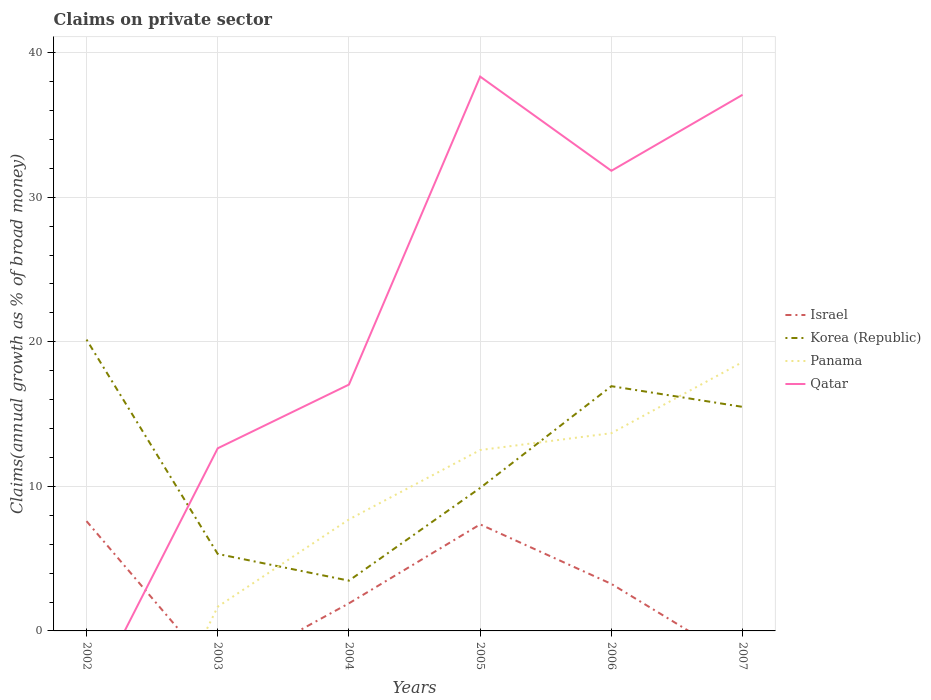How many different coloured lines are there?
Offer a very short reply. 4. Does the line corresponding to Panama intersect with the line corresponding to Israel?
Your response must be concise. Yes. Is the number of lines equal to the number of legend labels?
Your answer should be very brief. No. Across all years, what is the maximum percentage of broad money claimed on private sector in Panama?
Your response must be concise. 0. What is the total percentage of broad money claimed on private sector in Israel in the graph?
Provide a short and direct response. -5.46. What is the difference between the highest and the second highest percentage of broad money claimed on private sector in Korea (Republic)?
Offer a terse response. 16.68. What is the difference between the highest and the lowest percentage of broad money claimed on private sector in Qatar?
Provide a succinct answer. 3. Is the percentage of broad money claimed on private sector in Korea (Republic) strictly greater than the percentage of broad money claimed on private sector in Qatar over the years?
Your answer should be compact. No. How many lines are there?
Offer a terse response. 4. How many years are there in the graph?
Provide a short and direct response. 6. What is the difference between two consecutive major ticks on the Y-axis?
Give a very brief answer. 10. Are the values on the major ticks of Y-axis written in scientific E-notation?
Provide a succinct answer. No. Does the graph contain any zero values?
Make the answer very short. Yes. Does the graph contain grids?
Give a very brief answer. Yes. What is the title of the graph?
Ensure brevity in your answer.  Claims on private sector. What is the label or title of the X-axis?
Your answer should be compact. Years. What is the label or title of the Y-axis?
Keep it short and to the point. Claims(annual growth as % of broad money). What is the Claims(annual growth as % of broad money) of Israel in 2002?
Provide a short and direct response. 7.59. What is the Claims(annual growth as % of broad money) in Korea (Republic) in 2002?
Offer a very short reply. 20.15. What is the Claims(annual growth as % of broad money) of Israel in 2003?
Your response must be concise. 0. What is the Claims(annual growth as % of broad money) in Korea (Republic) in 2003?
Provide a succinct answer. 5.32. What is the Claims(annual growth as % of broad money) in Panama in 2003?
Offer a terse response. 1.67. What is the Claims(annual growth as % of broad money) of Qatar in 2003?
Make the answer very short. 12.63. What is the Claims(annual growth as % of broad money) in Israel in 2004?
Give a very brief answer. 1.91. What is the Claims(annual growth as % of broad money) in Korea (Republic) in 2004?
Your response must be concise. 3.48. What is the Claims(annual growth as % of broad money) of Panama in 2004?
Make the answer very short. 7.71. What is the Claims(annual growth as % of broad money) of Qatar in 2004?
Provide a short and direct response. 17.04. What is the Claims(annual growth as % of broad money) of Israel in 2005?
Provide a short and direct response. 7.37. What is the Claims(annual growth as % of broad money) of Korea (Republic) in 2005?
Provide a succinct answer. 9.89. What is the Claims(annual growth as % of broad money) of Panama in 2005?
Your answer should be very brief. 12.51. What is the Claims(annual growth as % of broad money) in Qatar in 2005?
Provide a succinct answer. 38.35. What is the Claims(annual growth as % of broad money) in Israel in 2006?
Keep it short and to the point. 3.25. What is the Claims(annual growth as % of broad money) in Korea (Republic) in 2006?
Offer a very short reply. 16.93. What is the Claims(annual growth as % of broad money) in Panama in 2006?
Provide a short and direct response. 13.68. What is the Claims(annual growth as % of broad money) of Qatar in 2006?
Your response must be concise. 31.83. What is the Claims(annual growth as % of broad money) of Korea (Republic) in 2007?
Your answer should be very brief. 15.5. What is the Claims(annual growth as % of broad money) in Panama in 2007?
Keep it short and to the point. 18.6. What is the Claims(annual growth as % of broad money) of Qatar in 2007?
Your answer should be compact. 37.09. Across all years, what is the maximum Claims(annual growth as % of broad money) of Israel?
Offer a very short reply. 7.59. Across all years, what is the maximum Claims(annual growth as % of broad money) in Korea (Republic)?
Provide a short and direct response. 20.15. Across all years, what is the maximum Claims(annual growth as % of broad money) of Panama?
Provide a succinct answer. 18.6. Across all years, what is the maximum Claims(annual growth as % of broad money) of Qatar?
Offer a terse response. 38.35. Across all years, what is the minimum Claims(annual growth as % of broad money) of Israel?
Your answer should be very brief. 0. Across all years, what is the minimum Claims(annual growth as % of broad money) of Korea (Republic)?
Offer a terse response. 3.48. What is the total Claims(annual growth as % of broad money) in Israel in the graph?
Your answer should be compact. 20.13. What is the total Claims(annual growth as % of broad money) in Korea (Republic) in the graph?
Offer a terse response. 71.27. What is the total Claims(annual growth as % of broad money) of Panama in the graph?
Provide a succinct answer. 54.18. What is the total Claims(annual growth as % of broad money) of Qatar in the graph?
Offer a very short reply. 136.94. What is the difference between the Claims(annual growth as % of broad money) in Korea (Republic) in 2002 and that in 2003?
Offer a terse response. 14.83. What is the difference between the Claims(annual growth as % of broad money) in Israel in 2002 and that in 2004?
Provide a succinct answer. 5.69. What is the difference between the Claims(annual growth as % of broad money) in Korea (Republic) in 2002 and that in 2004?
Your answer should be very brief. 16.68. What is the difference between the Claims(annual growth as % of broad money) of Israel in 2002 and that in 2005?
Offer a very short reply. 0.23. What is the difference between the Claims(annual growth as % of broad money) of Korea (Republic) in 2002 and that in 2005?
Your answer should be very brief. 10.26. What is the difference between the Claims(annual growth as % of broad money) of Israel in 2002 and that in 2006?
Your response must be concise. 4.34. What is the difference between the Claims(annual growth as % of broad money) of Korea (Republic) in 2002 and that in 2006?
Your response must be concise. 3.22. What is the difference between the Claims(annual growth as % of broad money) in Korea (Republic) in 2002 and that in 2007?
Provide a short and direct response. 4.65. What is the difference between the Claims(annual growth as % of broad money) of Korea (Republic) in 2003 and that in 2004?
Provide a short and direct response. 1.85. What is the difference between the Claims(annual growth as % of broad money) in Panama in 2003 and that in 2004?
Keep it short and to the point. -6.04. What is the difference between the Claims(annual growth as % of broad money) of Qatar in 2003 and that in 2004?
Provide a succinct answer. -4.41. What is the difference between the Claims(annual growth as % of broad money) in Korea (Republic) in 2003 and that in 2005?
Ensure brevity in your answer.  -4.57. What is the difference between the Claims(annual growth as % of broad money) of Panama in 2003 and that in 2005?
Your answer should be compact. -10.84. What is the difference between the Claims(annual growth as % of broad money) of Qatar in 2003 and that in 2005?
Make the answer very short. -25.71. What is the difference between the Claims(annual growth as % of broad money) of Korea (Republic) in 2003 and that in 2006?
Your answer should be compact. -11.61. What is the difference between the Claims(annual growth as % of broad money) in Panama in 2003 and that in 2006?
Your answer should be very brief. -12. What is the difference between the Claims(annual growth as % of broad money) of Qatar in 2003 and that in 2006?
Make the answer very short. -19.2. What is the difference between the Claims(annual growth as % of broad money) in Korea (Republic) in 2003 and that in 2007?
Provide a succinct answer. -10.17. What is the difference between the Claims(annual growth as % of broad money) in Panama in 2003 and that in 2007?
Your response must be concise. -16.93. What is the difference between the Claims(annual growth as % of broad money) of Qatar in 2003 and that in 2007?
Your answer should be very brief. -24.45. What is the difference between the Claims(annual growth as % of broad money) of Israel in 2004 and that in 2005?
Your answer should be compact. -5.46. What is the difference between the Claims(annual growth as % of broad money) of Korea (Republic) in 2004 and that in 2005?
Your answer should be very brief. -6.41. What is the difference between the Claims(annual growth as % of broad money) of Panama in 2004 and that in 2005?
Your answer should be compact. -4.8. What is the difference between the Claims(annual growth as % of broad money) in Qatar in 2004 and that in 2005?
Keep it short and to the point. -21.31. What is the difference between the Claims(annual growth as % of broad money) in Israel in 2004 and that in 2006?
Provide a succinct answer. -1.34. What is the difference between the Claims(annual growth as % of broad money) in Korea (Republic) in 2004 and that in 2006?
Make the answer very short. -13.45. What is the difference between the Claims(annual growth as % of broad money) of Panama in 2004 and that in 2006?
Offer a very short reply. -5.97. What is the difference between the Claims(annual growth as % of broad money) of Qatar in 2004 and that in 2006?
Keep it short and to the point. -14.79. What is the difference between the Claims(annual growth as % of broad money) of Korea (Republic) in 2004 and that in 2007?
Provide a short and direct response. -12.02. What is the difference between the Claims(annual growth as % of broad money) in Panama in 2004 and that in 2007?
Make the answer very short. -10.89. What is the difference between the Claims(annual growth as % of broad money) of Qatar in 2004 and that in 2007?
Keep it short and to the point. -20.05. What is the difference between the Claims(annual growth as % of broad money) of Israel in 2005 and that in 2006?
Keep it short and to the point. 4.12. What is the difference between the Claims(annual growth as % of broad money) in Korea (Republic) in 2005 and that in 2006?
Offer a terse response. -7.04. What is the difference between the Claims(annual growth as % of broad money) in Panama in 2005 and that in 2006?
Keep it short and to the point. -1.17. What is the difference between the Claims(annual growth as % of broad money) in Qatar in 2005 and that in 2006?
Your response must be concise. 6.52. What is the difference between the Claims(annual growth as % of broad money) of Korea (Republic) in 2005 and that in 2007?
Give a very brief answer. -5.61. What is the difference between the Claims(annual growth as % of broad money) in Panama in 2005 and that in 2007?
Provide a short and direct response. -6.09. What is the difference between the Claims(annual growth as % of broad money) in Qatar in 2005 and that in 2007?
Your answer should be compact. 1.26. What is the difference between the Claims(annual growth as % of broad money) of Korea (Republic) in 2006 and that in 2007?
Your answer should be compact. 1.43. What is the difference between the Claims(annual growth as % of broad money) of Panama in 2006 and that in 2007?
Your answer should be compact. -4.92. What is the difference between the Claims(annual growth as % of broad money) in Qatar in 2006 and that in 2007?
Your response must be concise. -5.26. What is the difference between the Claims(annual growth as % of broad money) in Israel in 2002 and the Claims(annual growth as % of broad money) in Korea (Republic) in 2003?
Your response must be concise. 2.27. What is the difference between the Claims(annual growth as % of broad money) of Israel in 2002 and the Claims(annual growth as % of broad money) of Panama in 2003?
Your response must be concise. 5.92. What is the difference between the Claims(annual growth as % of broad money) in Israel in 2002 and the Claims(annual growth as % of broad money) in Qatar in 2003?
Your response must be concise. -5.04. What is the difference between the Claims(annual growth as % of broad money) of Korea (Republic) in 2002 and the Claims(annual growth as % of broad money) of Panama in 2003?
Your answer should be very brief. 18.48. What is the difference between the Claims(annual growth as % of broad money) of Korea (Republic) in 2002 and the Claims(annual growth as % of broad money) of Qatar in 2003?
Your answer should be compact. 7.52. What is the difference between the Claims(annual growth as % of broad money) of Israel in 2002 and the Claims(annual growth as % of broad money) of Korea (Republic) in 2004?
Provide a succinct answer. 4.12. What is the difference between the Claims(annual growth as % of broad money) in Israel in 2002 and the Claims(annual growth as % of broad money) in Panama in 2004?
Your answer should be compact. -0.12. What is the difference between the Claims(annual growth as % of broad money) in Israel in 2002 and the Claims(annual growth as % of broad money) in Qatar in 2004?
Make the answer very short. -9.45. What is the difference between the Claims(annual growth as % of broad money) of Korea (Republic) in 2002 and the Claims(annual growth as % of broad money) of Panama in 2004?
Offer a terse response. 12.44. What is the difference between the Claims(annual growth as % of broad money) of Korea (Republic) in 2002 and the Claims(annual growth as % of broad money) of Qatar in 2004?
Your answer should be very brief. 3.11. What is the difference between the Claims(annual growth as % of broad money) in Israel in 2002 and the Claims(annual growth as % of broad money) in Korea (Republic) in 2005?
Your answer should be compact. -2.3. What is the difference between the Claims(annual growth as % of broad money) in Israel in 2002 and the Claims(annual growth as % of broad money) in Panama in 2005?
Make the answer very short. -4.92. What is the difference between the Claims(annual growth as % of broad money) in Israel in 2002 and the Claims(annual growth as % of broad money) in Qatar in 2005?
Offer a very short reply. -30.75. What is the difference between the Claims(annual growth as % of broad money) in Korea (Republic) in 2002 and the Claims(annual growth as % of broad money) in Panama in 2005?
Offer a terse response. 7.64. What is the difference between the Claims(annual growth as % of broad money) in Korea (Republic) in 2002 and the Claims(annual growth as % of broad money) in Qatar in 2005?
Your answer should be very brief. -18.19. What is the difference between the Claims(annual growth as % of broad money) in Israel in 2002 and the Claims(annual growth as % of broad money) in Korea (Republic) in 2006?
Make the answer very short. -9.33. What is the difference between the Claims(annual growth as % of broad money) of Israel in 2002 and the Claims(annual growth as % of broad money) of Panama in 2006?
Offer a very short reply. -6.08. What is the difference between the Claims(annual growth as % of broad money) in Israel in 2002 and the Claims(annual growth as % of broad money) in Qatar in 2006?
Provide a succinct answer. -24.24. What is the difference between the Claims(annual growth as % of broad money) in Korea (Republic) in 2002 and the Claims(annual growth as % of broad money) in Panama in 2006?
Your answer should be very brief. 6.47. What is the difference between the Claims(annual growth as % of broad money) of Korea (Republic) in 2002 and the Claims(annual growth as % of broad money) of Qatar in 2006?
Offer a terse response. -11.68. What is the difference between the Claims(annual growth as % of broad money) of Israel in 2002 and the Claims(annual growth as % of broad money) of Korea (Republic) in 2007?
Your answer should be compact. -7.9. What is the difference between the Claims(annual growth as % of broad money) in Israel in 2002 and the Claims(annual growth as % of broad money) in Panama in 2007?
Provide a succinct answer. -11.01. What is the difference between the Claims(annual growth as % of broad money) in Israel in 2002 and the Claims(annual growth as % of broad money) in Qatar in 2007?
Keep it short and to the point. -29.49. What is the difference between the Claims(annual growth as % of broad money) of Korea (Republic) in 2002 and the Claims(annual growth as % of broad money) of Panama in 2007?
Make the answer very short. 1.55. What is the difference between the Claims(annual growth as % of broad money) of Korea (Republic) in 2002 and the Claims(annual growth as % of broad money) of Qatar in 2007?
Offer a very short reply. -16.94. What is the difference between the Claims(annual growth as % of broad money) in Korea (Republic) in 2003 and the Claims(annual growth as % of broad money) in Panama in 2004?
Provide a succinct answer. -2.39. What is the difference between the Claims(annual growth as % of broad money) in Korea (Republic) in 2003 and the Claims(annual growth as % of broad money) in Qatar in 2004?
Give a very brief answer. -11.72. What is the difference between the Claims(annual growth as % of broad money) in Panama in 2003 and the Claims(annual growth as % of broad money) in Qatar in 2004?
Your response must be concise. -15.37. What is the difference between the Claims(annual growth as % of broad money) in Korea (Republic) in 2003 and the Claims(annual growth as % of broad money) in Panama in 2005?
Provide a succinct answer. -7.19. What is the difference between the Claims(annual growth as % of broad money) in Korea (Republic) in 2003 and the Claims(annual growth as % of broad money) in Qatar in 2005?
Provide a succinct answer. -33.02. What is the difference between the Claims(annual growth as % of broad money) of Panama in 2003 and the Claims(annual growth as % of broad money) of Qatar in 2005?
Provide a succinct answer. -36.67. What is the difference between the Claims(annual growth as % of broad money) of Korea (Republic) in 2003 and the Claims(annual growth as % of broad money) of Panama in 2006?
Offer a terse response. -8.36. What is the difference between the Claims(annual growth as % of broad money) of Korea (Republic) in 2003 and the Claims(annual growth as % of broad money) of Qatar in 2006?
Make the answer very short. -26.51. What is the difference between the Claims(annual growth as % of broad money) of Panama in 2003 and the Claims(annual growth as % of broad money) of Qatar in 2006?
Offer a very short reply. -30.16. What is the difference between the Claims(annual growth as % of broad money) in Korea (Republic) in 2003 and the Claims(annual growth as % of broad money) in Panama in 2007?
Your answer should be compact. -13.28. What is the difference between the Claims(annual growth as % of broad money) in Korea (Republic) in 2003 and the Claims(annual growth as % of broad money) in Qatar in 2007?
Your answer should be compact. -31.76. What is the difference between the Claims(annual growth as % of broad money) of Panama in 2003 and the Claims(annual growth as % of broad money) of Qatar in 2007?
Make the answer very short. -35.41. What is the difference between the Claims(annual growth as % of broad money) in Israel in 2004 and the Claims(annual growth as % of broad money) in Korea (Republic) in 2005?
Your answer should be very brief. -7.98. What is the difference between the Claims(annual growth as % of broad money) in Israel in 2004 and the Claims(annual growth as % of broad money) in Panama in 2005?
Give a very brief answer. -10.6. What is the difference between the Claims(annual growth as % of broad money) of Israel in 2004 and the Claims(annual growth as % of broad money) of Qatar in 2005?
Your answer should be very brief. -36.44. What is the difference between the Claims(annual growth as % of broad money) in Korea (Republic) in 2004 and the Claims(annual growth as % of broad money) in Panama in 2005?
Offer a very short reply. -9.04. What is the difference between the Claims(annual growth as % of broad money) in Korea (Republic) in 2004 and the Claims(annual growth as % of broad money) in Qatar in 2005?
Ensure brevity in your answer.  -34.87. What is the difference between the Claims(annual growth as % of broad money) in Panama in 2004 and the Claims(annual growth as % of broad money) in Qatar in 2005?
Your answer should be compact. -30.63. What is the difference between the Claims(annual growth as % of broad money) of Israel in 2004 and the Claims(annual growth as % of broad money) of Korea (Republic) in 2006?
Provide a short and direct response. -15.02. What is the difference between the Claims(annual growth as % of broad money) of Israel in 2004 and the Claims(annual growth as % of broad money) of Panama in 2006?
Ensure brevity in your answer.  -11.77. What is the difference between the Claims(annual growth as % of broad money) of Israel in 2004 and the Claims(annual growth as % of broad money) of Qatar in 2006?
Offer a terse response. -29.92. What is the difference between the Claims(annual growth as % of broad money) in Korea (Republic) in 2004 and the Claims(annual growth as % of broad money) in Panama in 2006?
Ensure brevity in your answer.  -10.2. What is the difference between the Claims(annual growth as % of broad money) in Korea (Republic) in 2004 and the Claims(annual growth as % of broad money) in Qatar in 2006?
Give a very brief answer. -28.35. What is the difference between the Claims(annual growth as % of broad money) of Panama in 2004 and the Claims(annual growth as % of broad money) of Qatar in 2006?
Offer a very short reply. -24.12. What is the difference between the Claims(annual growth as % of broad money) in Israel in 2004 and the Claims(annual growth as % of broad money) in Korea (Republic) in 2007?
Your response must be concise. -13.59. What is the difference between the Claims(annual growth as % of broad money) in Israel in 2004 and the Claims(annual growth as % of broad money) in Panama in 2007?
Keep it short and to the point. -16.69. What is the difference between the Claims(annual growth as % of broad money) in Israel in 2004 and the Claims(annual growth as % of broad money) in Qatar in 2007?
Provide a succinct answer. -35.18. What is the difference between the Claims(annual growth as % of broad money) in Korea (Republic) in 2004 and the Claims(annual growth as % of broad money) in Panama in 2007?
Ensure brevity in your answer.  -15.12. What is the difference between the Claims(annual growth as % of broad money) of Korea (Republic) in 2004 and the Claims(annual growth as % of broad money) of Qatar in 2007?
Your answer should be very brief. -33.61. What is the difference between the Claims(annual growth as % of broad money) of Panama in 2004 and the Claims(annual growth as % of broad money) of Qatar in 2007?
Offer a terse response. -29.38. What is the difference between the Claims(annual growth as % of broad money) of Israel in 2005 and the Claims(annual growth as % of broad money) of Korea (Republic) in 2006?
Make the answer very short. -9.56. What is the difference between the Claims(annual growth as % of broad money) in Israel in 2005 and the Claims(annual growth as % of broad money) in Panama in 2006?
Your response must be concise. -6.31. What is the difference between the Claims(annual growth as % of broad money) in Israel in 2005 and the Claims(annual growth as % of broad money) in Qatar in 2006?
Provide a short and direct response. -24.46. What is the difference between the Claims(annual growth as % of broad money) of Korea (Republic) in 2005 and the Claims(annual growth as % of broad money) of Panama in 2006?
Offer a terse response. -3.79. What is the difference between the Claims(annual growth as % of broad money) in Korea (Republic) in 2005 and the Claims(annual growth as % of broad money) in Qatar in 2006?
Offer a very short reply. -21.94. What is the difference between the Claims(annual growth as % of broad money) in Panama in 2005 and the Claims(annual growth as % of broad money) in Qatar in 2006?
Your response must be concise. -19.32. What is the difference between the Claims(annual growth as % of broad money) in Israel in 2005 and the Claims(annual growth as % of broad money) in Korea (Republic) in 2007?
Your answer should be compact. -8.13. What is the difference between the Claims(annual growth as % of broad money) of Israel in 2005 and the Claims(annual growth as % of broad money) of Panama in 2007?
Offer a terse response. -11.23. What is the difference between the Claims(annual growth as % of broad money) in Israel in 2005 and the Claims(annual growth as % of broad money) in Qatar in 2007?
Your answer should be very brief. -29.72. What is the difference between the Claims(annual growth as % of broad money) in Korea (Republic) in 2005 and the Claims(annual growth as % of broad money) in Panama in 2007?
Your response must be concise. -8.71. What is the difference between the Claims(annual growth as % of broad money) in Korea (Republic) in 2005 and the Claims(annual growth as % of broad money) in Qatar in 2007?
Your answer should be very brief. -27.2. What is the difference between the Claims(annual growth as % of broad money) of Panama in 2005 and the Claims(annual growth as % of broad money) of Qatar in 2007?
Provide a succinct answer. -24.58. What is the difference between the Claims(annual growth as % of broad money) of Israel in 2006 and the Claims(annual growth as % of broad money) of Korea (Republic) in 2007?
Your response must be concise. -12.25. What is the difference between the Claims(annual growth as % of broad money) in Israel in 2006 and the Claims(annual growth as % of broad money) in Panama in 2007?
Ensure brevity in your answer.  -15.35. What is the difference between the Claims(annual growth as % of broad money) of Israel in 2006 and the Claims(annual growth as % of broad money) of Qatar in 2007?
Offer a terse response. -33.84. What is the difference between the Claims(annual growth as % of broad money) in Korea (Republic) in 2006 and the Claims(annual growth as % of broad money) in Panama in 2007?
Your answer should be very brief. -1.67. What is the difference between the Claims(annual growth as % of broad money) of Korea (Republic) in 2006 and the Claims(annual growth as % of broad money) of Qatar in 2007?
Ensure brevity in your answer.  -20.16. What is the difference between the Claims(annual growth as % of broad money) of Panama in 2006 and the Claims(annual growth as % of broad money) of Qatar in 2007?
Provide a short and direct response. -23.41. What is the average Claims(annual growth as % of broad money) of Israel per year?
Your answer should be compact. 3.35. What is the average Claims(annual growth as % of broad money) of Korea (Republic) per year?
Provide a short and direct response. 11.88. What is the average Claims(annual growth as % of broad money) in Panama per year?
Offer a very short reply. 9.03. What is the average Claims(annual growth as % of broad money) of Qatar per year?
Ensure brevity in your answer.  22.82. In the year 2002, what is the difference between the Claims(annual growth as % of broad money) in Israel and Claims(annual growth as % of broad money) in Korea (Republic)?
Your answer should be compact. -12.56. In the year 2003, what is the difference between the Claims(annual growth as % of broad money) in Korea (Republic) and Claims(annual growth as % of broad money) in Panama?
Give a very brief answer. 3.65. In the year 2003, what is the difference between the Claims(annual growth as % of broad money) of Korea (Republic) and Claims(annual growth as % of broad money) of Qatar?
Ensure brevity in your answer.  -7.31. In the year 2003, what is the difference between the Claims(annual growth as % of broad money) in Panama and Claims(annual growth as % of broad money) in Qatar?
Your answer should be very brief. -10.96. In the year 2004, what is the difference between the Claims(annual growth as % of broad money) of Israel and Claims(annual growth as % of broad money) of Korea (Republic)?
Keep it short and to the point. -1.57. In the year 2004, what is the difference between the Claims(annual growth as % of broad money) in Israel and Claims(annual growth as % of broad money) in Panama?
Make the answer very short. -5.8. In the year 2004, what is the difference between the Claims(annual growth as % of broad money) in Israel and Claims(annual growth as % of broad money) in Qatar?
Provide a short and direct response. -15.13. In the year 2004, what is the difference between the Claims(annual growth as % of broad money) of Korea (Republic) and Claims(annual growth as % of broad money) of Panama?
Your answer should be very brief. -4.24. In the year 2004, what is the difference between the Claims(annual growth as % of broad money) of Korea (Republic) and Claims(annual growth as % of broad money) of Qatar?
Ensure brevity in your answer.  -13.56. In the year 2004, what is the difference between the Claims(annual growth as % of broad money) of Panama and Claims(annual growth as % of broad money) of Qatar?
Give a very brief answer. -9.33. In the year 2005, what is the difference between the Claims(annual growth as % of broad money) in Israel and Claims(annual growth as % of broad money) in Korea (Republic)?
Keep it short and to the point. -2.52. In the year 2005, what is the difference between the Claims(annual growth as % of broad money) in Israel and Claims(annual growth as % of broad money) in Panama?
Offer a terse response. -5.14. In the year 2005, what is the difference between the Claims(annual growth as % of broad money) of Israel and Claims(annual growth as % of broad money) of Qatar?
Offer a terse response. -30.98. In the year 2005, what is the difference between the Claims(annual growth as % of broad money) in Korea (Republic) and Claims(annual growth as % of broad money) in Panama?
Your response must be concise. -2.62. In the year 2005, what is the difference between the Claims(annual growth as % of broad money) in Korea (Republic) and Claims(annual growth as % of broad money) in Qatar?
Your answer should be very brief. -28.46. In the year 2005, what is the difference between the Claims(annual growth as % of broad money) of Panama and Claims(annual growth as % of broad money) of Qatar?
Keep it short and to the point. -25.83. In the year 2006, what is the difference between the Claims(annual growth as % of broad money) in Israel and Claims(annual growth as % of broad money) in Korea (Republic)?
Your response must be concise. -13.68. In the year 2006, what is the difference between the Claims(annual growth as % of broad money) of Israel and Claims(annual growth as % of broad money) of Panama?
Offer a very short reply. -10.43. In the year 2006, what is the difference between the Claims(annual growth as % of broad money) of Israel and Claims(annual growth as % of broad money) of Qatar?
Make the answer very short. -28.58. In the year 2006, what is the difference between the Claims(annual growth as % of broad money) of Korea (Republic) and Claims(annual growth as % of broad money) of Panama?
Give a very brief answer. 3.25. In the year 2006, what is the difference between the Claims(annual growth as % of broad money) in Korea (Republic) and Claims(annual growth as % of broad money) in Qatar?
Your answer should be compact. -14.9. In the year 2006, what is the difference between the Claims(annual growth as % of broad money) in Panama and Claims(annual growth as % of broad money) in Qatar?
Keep it short and to the point. -18.15. In the year 2007, what is the difference between the Claims(annual growth as % of broad money) of Korea (Republic) and Claims(annual growth as % of broad money) of Panama?
Your response must be concise. -3.1. In the year 2007, what is the difference between the Claims(annual growth as % of broad money) in Korea (Republic) and Claims(annual growth as % of broad money) in Qatar?
Provide a succinct answer. -21.59. In the year 2007, what is the difference between the Claims(annual growth as % of broad money) of Panama and Claims(annual growth as % of broad money) of Qatar?
Keep it short and to the point. -18.49. What is the ratio of the Claims(annual growth as % of broad money) in Korea (Republic) in 2002 to that in 2003?
Your response must be concise. 3.79. What is the ratio of the Claims(annual growth as % of broad money) in Israel in 2002 to that in 2004?
Make the answer very short. 3.98. What is the ratio of the Claims(annual growth as % of broad money) in Korea (Republic) in 2002 to that in 2004?
Provide a short and direct response. 5.8. What is the ratio of the Claims(annual growth as % of broad money) of Israel in 2002 to that in 2005?
Your response must be concise. 1.03. What is the ratio of the Claims(annual growth as % of broad money) in Korea (Republic) in 2002 to that in 2005?
Keep it short and to the point. 2.04. What is the ratio of the Claims(annual growth as % of broad money) in Israel in 2002 to that in 2006?
Give a very brief answer. 2.34. What is the ratio of the Claims(annual growth as % of broad money) of Korea (Republic) in 2002 to that in 2006?
Keep it short and to the point. 1.19. What is the ratio of the Claims(annual growth as % of broad money) in Korea (Republic) in 2002 to that in 2007?
Give a very brief answer. 1.3. What is the ratio of the Claims(annual growth as % of broad money) in Korea (Republic) in 2003 to that in 2004?
Provide a succinct answer. 1.53. What is the ratio of the Claims(annual growth as % of broad money) in Panama in 2003 to that in 2004?
Give a very brief answer. 0.22. What is the ratio of the Claims(annual growth as % of broad money) of Qatar in 2003 to that in 2004?
Offer a very short reply. 0.74. What is the ratio of the Claims(annual growth as % of broad money) in Korea (Republic) in 2003 to that in 2005?
Your response must be concise. 0.54. What is the ratio of the Claims(annual growth as % of broad money) in Panama in 2003 to that in 2005?
Offer a very short reply. 0.13. What is the ratio of the Claims(annual growth as % of broad money) of Qatar in 2003 to that in 2005?
Provide a short and direct response. 0.33. What is the ratio of the Claims(annual growth as % of broad money) in Korea (Republic) in 2003 to that in 2006?
Provide a short and direct response. 0.31. What is the ratio of the Claims(annual growth as % of broad money) of Panama in 2003 to that in 2006?
Provide a short and direct response. 0.12. What is the ratio of the Claims(annual growth as % of broad money) in Qatar in 2003 to that in 2006?
Ensure brevity in your answer.  0.4. What is the ratio of the Claims(annual growth as % of broad money) of Korea (Republic) in 2003 to that in 2007?
Your response must be concise. 0.34. What is the ratio of the Claims(annual growth as % of broad money) in Panama in 2003 to that in 2007?
Your answer should be compact. 0.09. What is the ratio of the Claims(annual growth as % of broad money) in Qatar in 2003 to that in 2007?
Your response must be concise. 0.34. What is the ratio of the Claims(annual growth as % of broad money) in Israel in 2004 to that in 2005?
Make the answer very short. 0.26. What is the ratio of the Claims(annual growth as % of broad money) of Korea (Republic) in 2004 to that in 2005?
Keep it short and to the point. 0.35. What is the ratio of the Claims(annual growth as % of broad money) of Panama in 2004 to that in 2005?
Your answer should be compact. 0.62. What is the ratio of the Claims(annual growth as % of broad money) in Qatar in 2004 to that in 2005?
Provide a short and direct response. 0.44. What is the ratio of the Claims(annual growth as % of broad money) of Israel in 2004 to that in 2006?
Offer a terse response. 0.59. What is the ratio of the Claims(annual growth as % of broad money) in Korea (Republic) in 2004 to that in 2006?
Keep it short and to the point. 0.21. What is the ratio of the Claims(annual growth as % of broad money) of Panama in 2004 to that in 2006?
Make the answer very short. 0.56. What is the ratio of the Claims(annual growth as % of broad money) in Qatar in 2004 to that in 2006?
Your answer should be compact. 0.54. What is the ratio of the Claims(annual growth as % of broad money) of Korea (Republic) in 2004 to that in 2007?
Ensure brevity in your answer.  0.22. What is the ratio of the Claims(annual growth as % of broad money) in Panama in 2004 to that in 2007?
Ensure brevity in your answer.  0.41. What is the ratio of the Claims(annual growth as % of broad money) in Qatar in 2004 to that in 2007?
Ensure brevity in your answer.  0.46. What is the ratio of the Claims(annual growth as % of broad money) in Israel in 2005 to that in 2006?
Provide a short and direct response. 2.27. What is the ratio of the Claims(annual growth as % of broad money) in Korea (Republic) in 2005 to that in 2006?
Give a very brief answer. 0.58. What is the ratio of the Claims(annual growth as % of broad money) in Panama in 2005 to that in 2006?
Keep it short and to the point. 0.91. What is the ratio of the Claims(annual growth as % of broad money) of Qatar in 2005 to that in 2006?
Give a very brief answer. 1.2. What is the ratio of the Claims(annual growth as % of broad money) of Korea (Republic) in 2005 to that in 2007?
Give a very brief answer. 0.64. What is the ratio of the Claims(annual growth as % of broad money) of Panama in 2005 to that in 2007?
Your answer should be very brief. 0.67. What is the ratio of the Claims(annual growth as % of broad money) of Qatar in 2005 to that in 2007?
Provide a short and direct response. 1.03. What is the ratio of the Claims(annual growth as % of broad money) in Korea (Republic) in 2006 to that in 2007?
Provide a short and direct response. 1.09. What is the ratio of the Claims(annual growth as % of broad money) in Panama in 2006 to that in 2007?
Provide a succinct answer. 0.74. What is the ratio of the Claims(annual growth as % of broad money) of Qatar in 2006 to that in 2007?
Offer a terse response. 0.86. What is the difference between the highest and the second highest Claims(annual growth as % of broad money) in Israel?
Provide a succinct answer. 0.23. What is the difference between the highest and the second highest Claims(annual growth as % of broad money) of Korea (Republic)?
Offer a terse response. 3.22. What is the difference between the highest and the second highest Claims(annual growth as % of broad money) of Panama?
Keep it short and to the point. 4.92. What is the difference between the highest and the second highest Claims(annual growth as % of broad money) in Qatar?
Make the answer very short. 1.26. What is the difference between the highest and the lowest Claims(annual growth as % of broad money) in Israel?
Provide a short and direct response. 7.59. What is the difference between the highest and the lowest Claims(annual growth as % of broad money) of Korea (Republic)?
Provide a short and direct response. 16.68. What is the difference between the highest and the lowest Claims(annual growth as % of broad money) in Panama?
Provide a succinct answer. 18.6. What is the difference between the highest and the lowest Claims(annual growth as % of broad money) of Qatar?
Give a very brief answer. 38.35. 